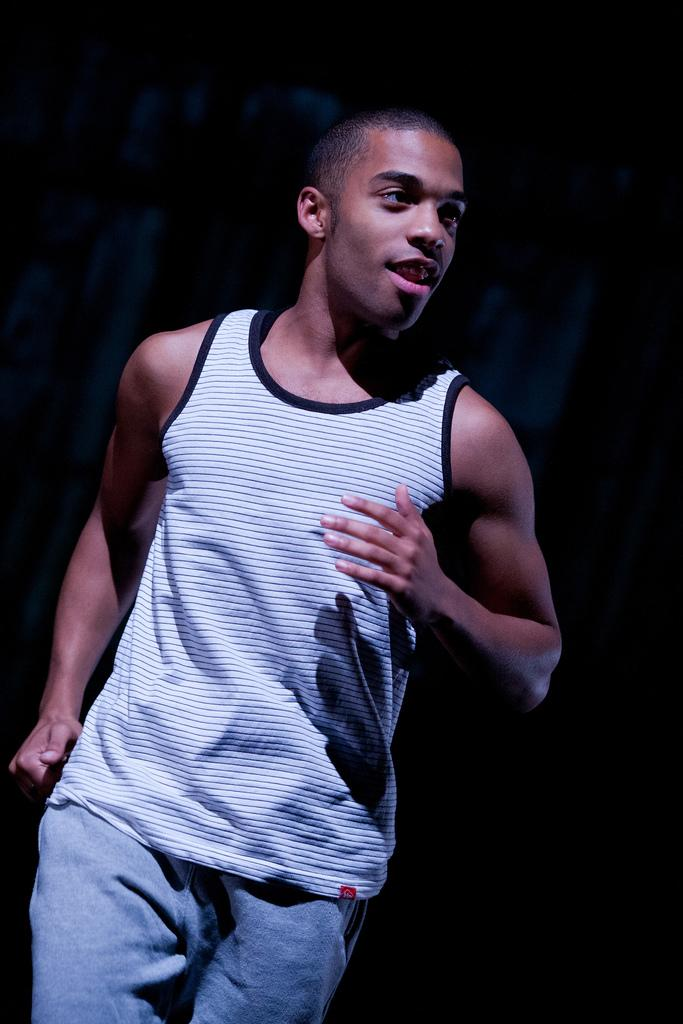What is present in the image? There is a person in the image. Can you describe the position of the person in the image? The person is standing on the ground. What type of cave can be seen in the background of the image? There is no cave present in the image; it only features a person standing on the ground. 